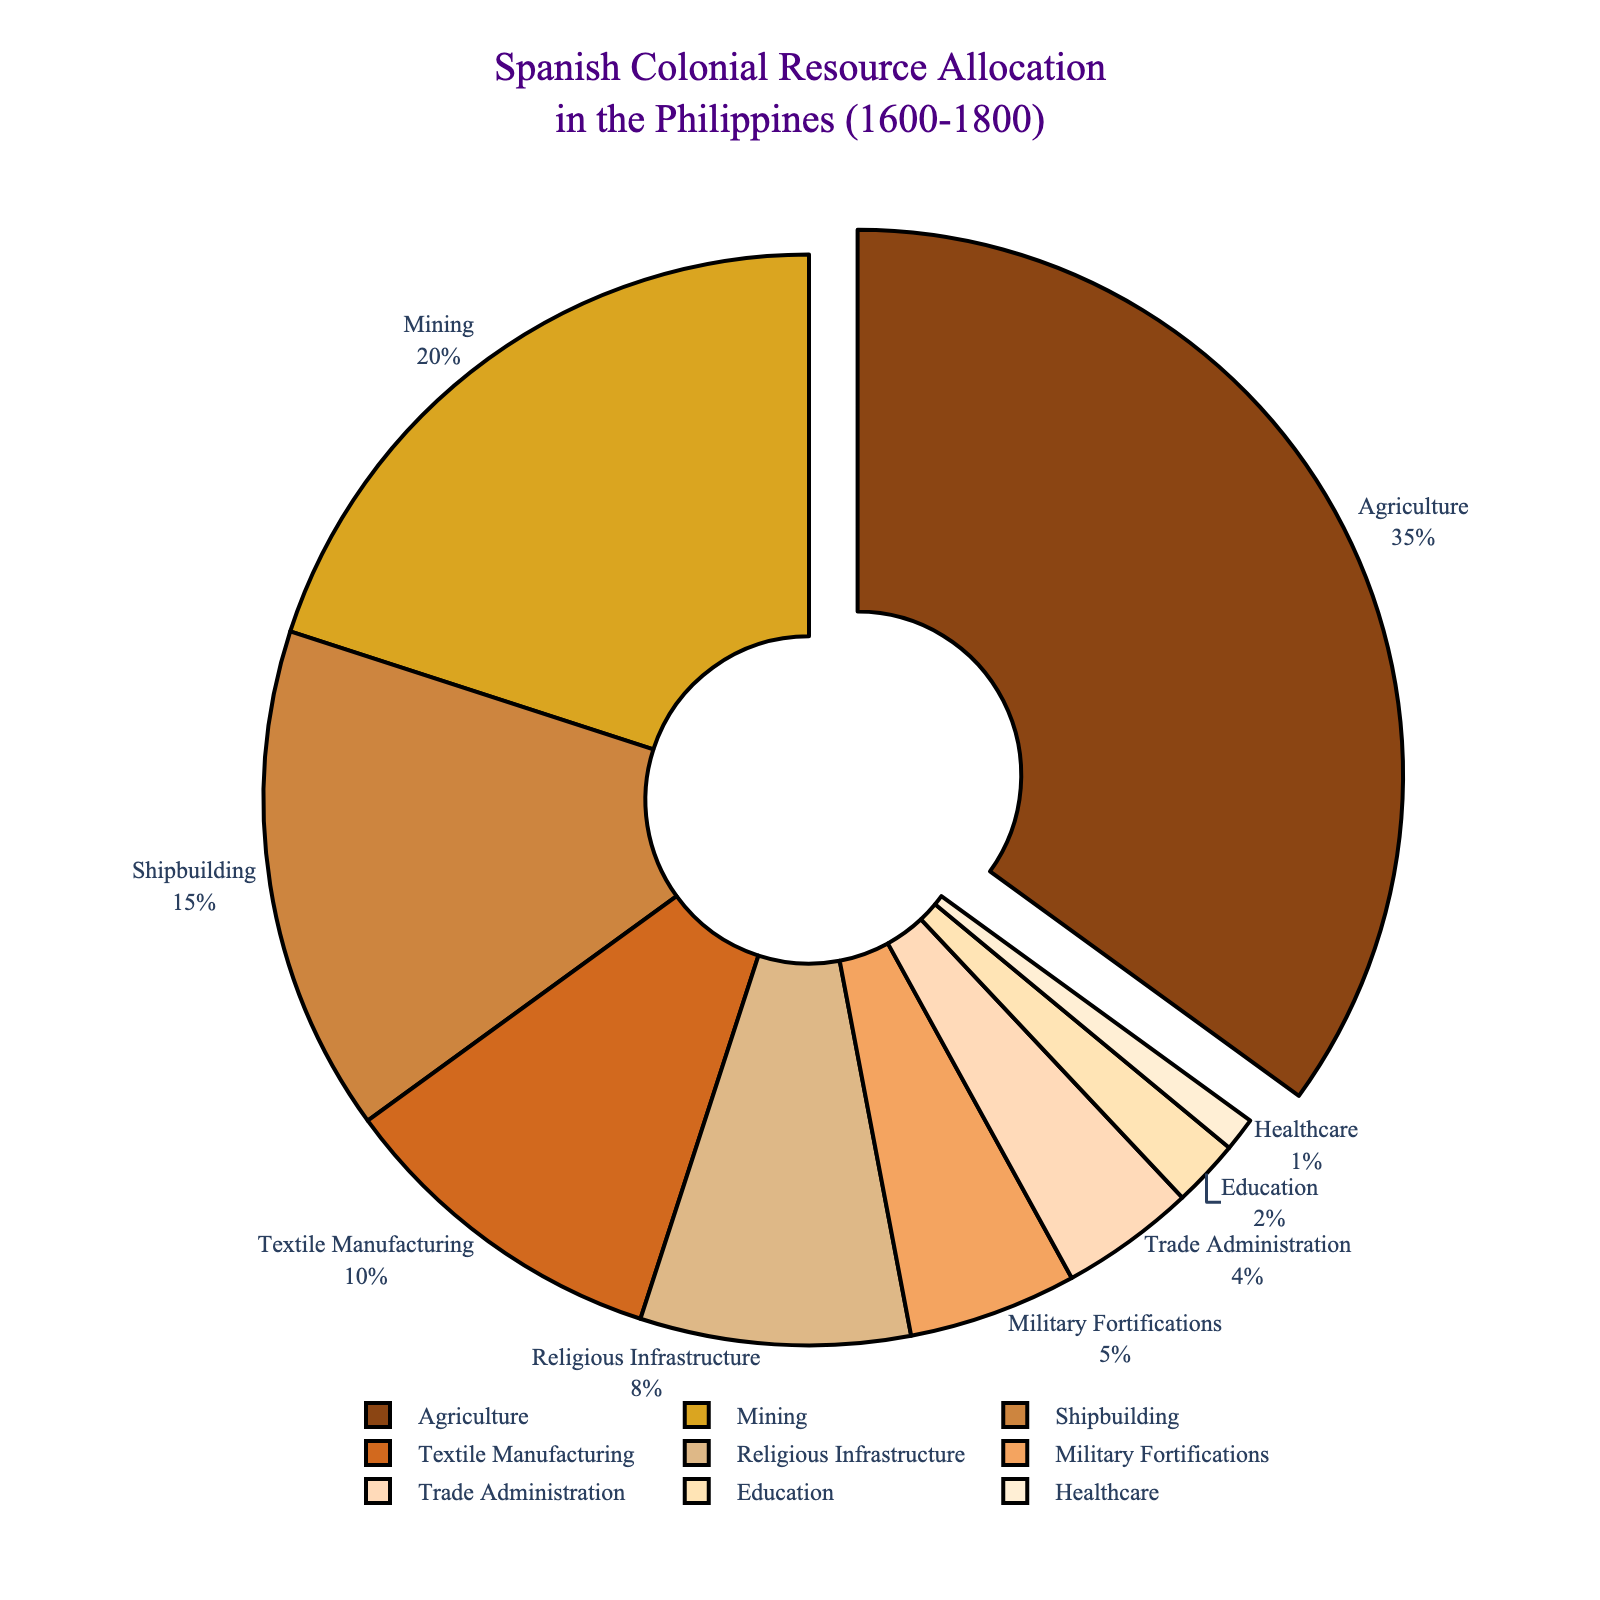What is the largest sector in the allocation of Spanish colonial resources? To determine the largest sector, we examine the largest percentage value in the pie chart. Agriculture has 35%, which is the highest among the sectors.
Answer: Agriculture How much more percentage was allocated to Mining compared to Trade Administration? We need to find the percentage values for Mining and Trade Administration and then subtract the latter from the former: 20% (Mining) - 4% (Trade Administration) = 16%.
Answer: 16% What percentage of resources was allocated to non-agricultural industries? Sum the percentages of all sectors except Agriculture: 20 + 15 + 10 + 8 + 5 + 4 + 2 + 1 = 65%.
Answer: 65% Which sector received just over one-third of the total allocation? One-third of the pie chart is approximately 33.33%. The sector with a percentage just over this is Agriculture with 35%.
Answer: Agriculture Rank the top three sectors by allocation percentage. First, identify the three sectors with the highest percentages: Agriculture (35%), Mining (20%), and Shipbuilding (15%).
Answer: Agriculture, Mining, Shipbuilding Is the combined allocation of Military Fortifications and Religious Infrastructure greater or less than Textile Manufacturing? Sum the percentages of Military Fortifications and Religious Infrastructure and compare with Textile Manufacturing: 5% (Military Fortifications) + 8% (Religious Infrastructure) = 13%. Textile Manufacturing is 10%, so 13% is greater.
Answer: Greater What sectors received less than 10% of the resources each? Identify all sectors with percentages less than 10%: Religious Infrastructure (8%), Military Fortifications (5%), Trade Administration (4%), Education (2%), Healthcare (1%).
Answer: Religious Infrastructure, Military Fortifications, Trade Administration, Education, Healthcare If resources were reallocated equally among Agriculture and Mining, what would be the new percentage for both sectors? Calculate the total percentage for Agriculture and Mining: 35% + 20% = 55%. Divide this equally: 55% / 2 = 27.5%.
Answer: 27.5% each What is the difference between the allocations for Shipbuilding and Education? Subtract the percentage for Education from Shipbuilding: 15% (Shipbuilding) - 2% (Education) = 13%.
Answer: 13% Which sector has a larger allocation, Healthcare or Trade Administration, and by how much? Trade Administration has 4% and Healthcare has 1%. Subtract to find the difference: 4% - 1% = 3%.
Answer: Trade Administration by 3% 